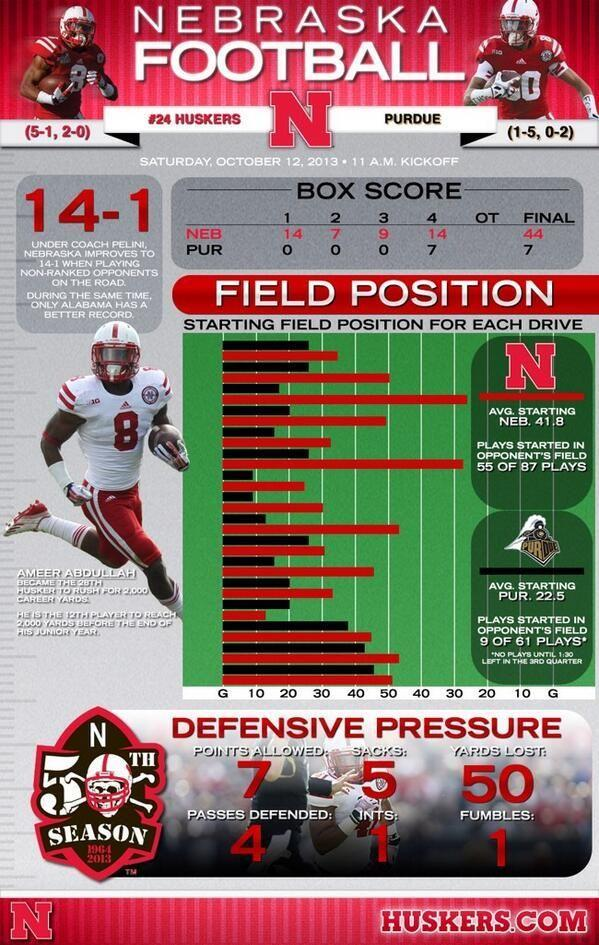What are the points allowed?
Answer the question with a short phrase. 7 What are the yards lost? 50 